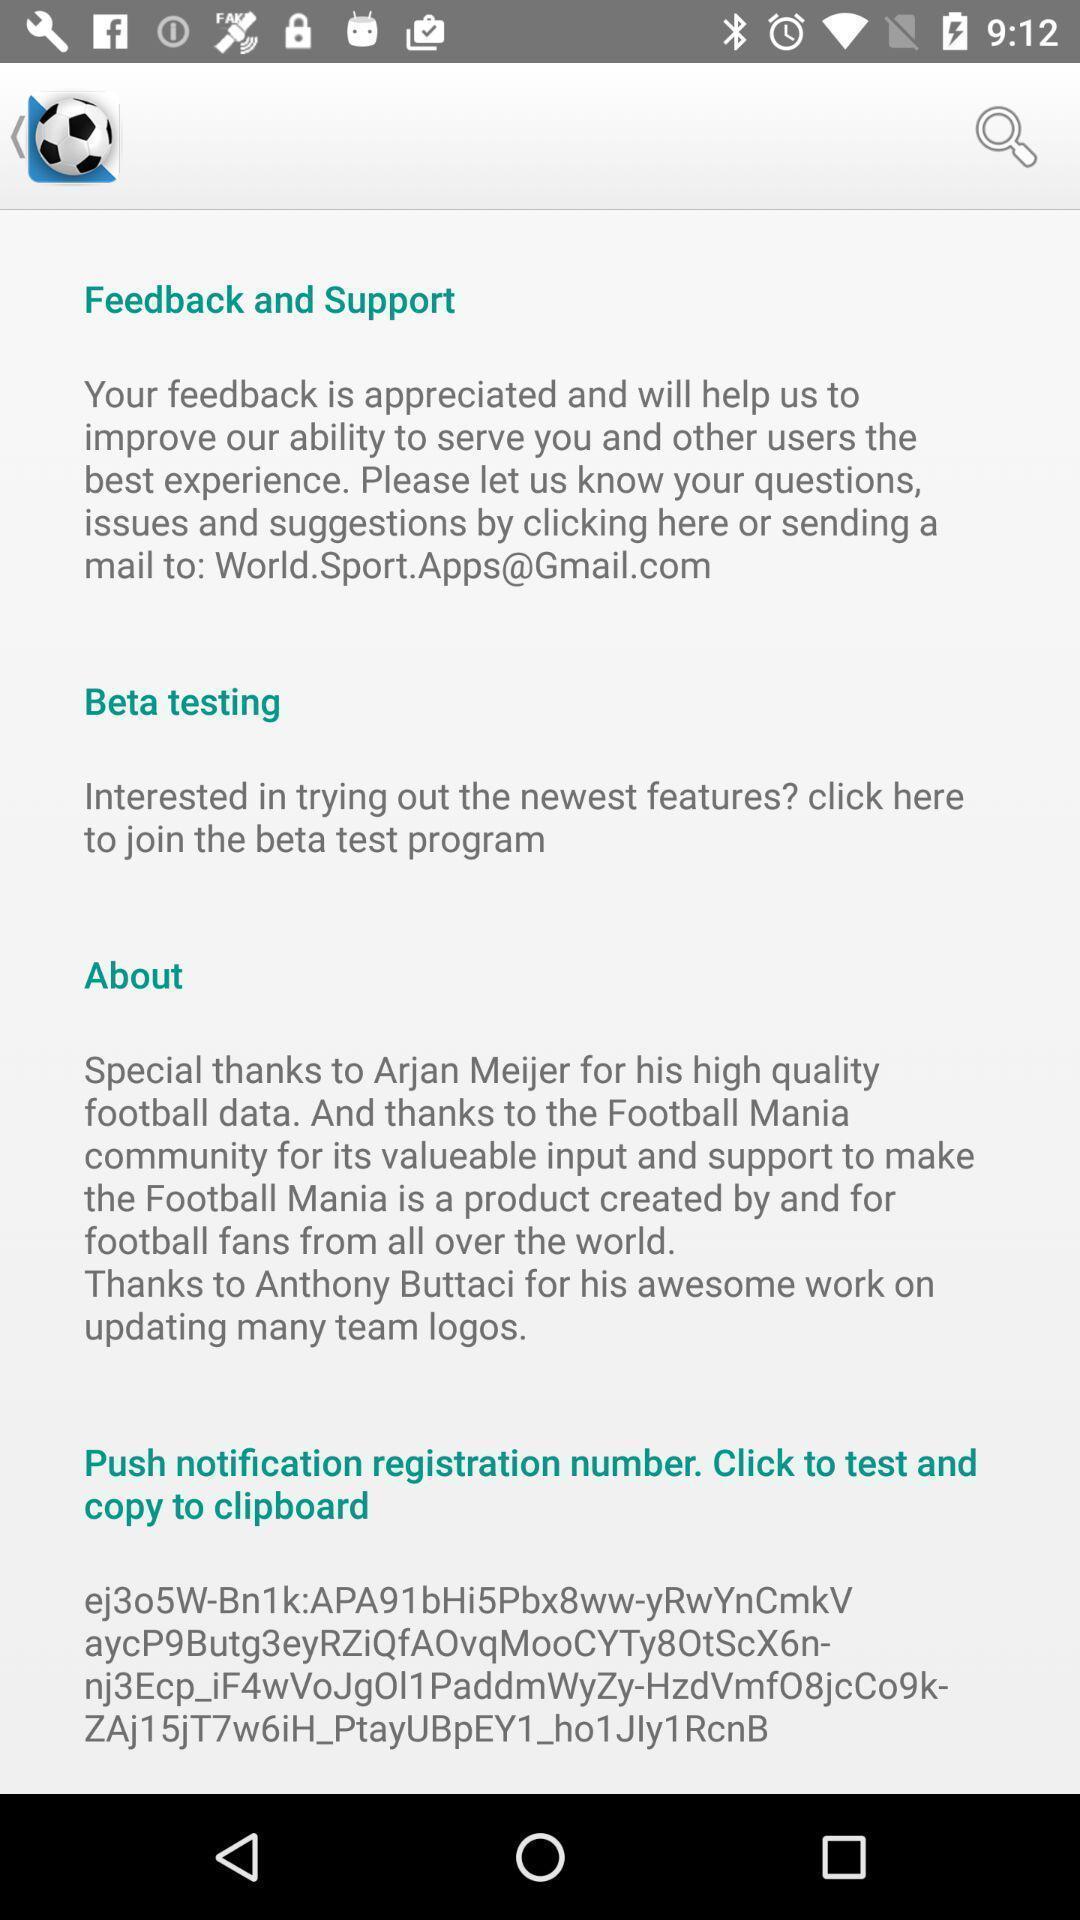Give me a summary of this screen capture. Screen showing feedback and support page. 